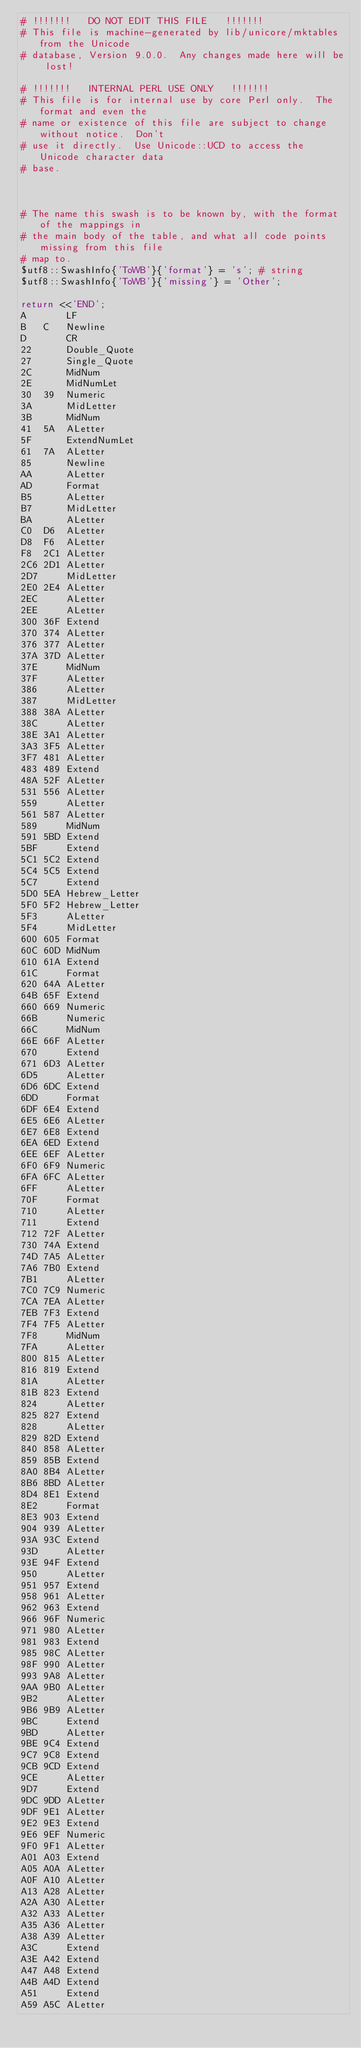<code> <loc_0><loc_0><loc_500><loc_500><_Perl_># !!!!!!!   DO NOT EDIT THIS FILE   !!!!!!!
# This file is machine-generated by lib/unicore/mktables from the Unicode
# database, Version 9.0.0.  Any changes made here will be lost!

# !!!!!!!   INTERNAL PERL USE ONLY   !!!!!!!
# This file is for internal use by core Perl only.  The format and even the
# name or existence of this file are subject to change without notice.  Don't
# use it directly.  Use Unicode::UCD to access the Unicode character data
# base.



# The name this swash is to be known by, with the format of the mappings in
# the main body of the table, and what all code points missing from this file
# map to.
$utf8::SwashInfo{'ToWB'}{'format'} = 's'; # string
$utf8::SwashInfo{'ToWB'}{'missing'} = 'Other';

return <<'END';
A		LF
B	C	Newline
D		CR
22		Double_Quote
27		Single_Quote
2C		MidNum
2E		MidNumLet
30	39	Numeric
3A		MidLetter
3B		MidNum
41	5A	ALetter
5F		ExtendNumLet
61	7A	ALetter
85		Newline
AA		ALetter
AD		Format
B5		ALetter
B7		MidLetter
BA		ALetter
C0	D6	ALetter
D8	F6	ALetter
F8	2C1	ALetter
2C6	2D1	ALetter
2D7		MidLetter
2E0	2E4	ALetter
2EC		ALetter
2EE		ALetter
300	36F	Extend
370	374	ALetter
376	377	ALetter
37A	37D	ALetter
37E		MidNum
37F		ALetter
386		ALetter
387		MidLetter
388	38A	ALetter
38C		ALetter
38E	3A1	ALetter
3A3	3F5	ALetter
3F7	481	ALetter
483	489	Extend
48A	52F	ALetter
531	556	ALetter
559		ALetter
561	587	ALetter
589		MidNum
591	5BD	Extend
5BF		Extend
5C1	5C2	Extend
5C4	5C5	Extend
5C7		Extend
5D0	5EA	Hebrew_Letter
5F0	5F2	Hebrew_Letter
5F3		ALetter
5F4		MidLetter
600	605	Format
60C	60D	MidNum
610	61A	Extend
61C		Format
620	64A	ALetter
64B	65F	Extend
660	669	Numeric
66B		Numeric
66C		MidNum
66E	66F	ALetter
670		Extend
671	6D3	ALetter
6D5		ALetter
6D6	6DC	Extend
6DD		Format
6DF	6E4	Extend
6E5	6E6	ALetter
6E7	6E8	Extend
6EA	6ED	Extend
6EE	6EF	ALetter
6F0	6F9	Numeric
6FA	6FC	ALetter
6FF		ALetter
70F		Format
710		ALetter
711		Extend
712	72F	ALetter
730	74A	Extend
74D	7A5	ALetter
7A6	7B0	Extend
7B1		ALetter
7C0	7C9	Numeric
7CA	7EA	ALetter
7EB	7F3	Extend
7F4	7F5	ALetter
7F8		MidNum
7FA		ALetter
800	815	ALetter
816	819	Extend
81A		ALetter
81B	823	Extend
824		ALetter
825	827	Extend
828		ALetter
829	82D	Extend
840	858	ALetter
859	85B	Extend
8A0	8B4	ALetter
8B6	8BD	ALetter
8D4	8E1	Extend
8E2		Format
8E3	903	Extend
904	939	ALetter
93A	93C	Extend
93D		ALetter
93E	94F	Extend
950		ALetter
951	957	Extend
958	961	ALetter
962	963	Extend
966	96F	Numeric
971	980	ALetter
981	983	Extend
985	98C	ALetter
98F	990	ALetter
993	9A8	ALetter
9AA	9B0	ALetter
9B2		ALetter
9B6	9B9	ALetter
9BC		Extend
9BD		ALetter
9BE	9C4	Extend
9C7	9C8	Extend
9CB	9CD	Extend
9CE		ALetter
9D7		Extend
9DC	9DD	ALetter
9DF	9E1	ALetter
9E2	9E3	Extend
9E6	9EF	Numeric
9F0	9F1	ALetter
A01	A03	Extend
A05	A0A	ALetter
A0F	A10	ALetter
A13	A28	ALetter
A2A	A30	ALetter
A32	A33	ALetter
A35	A36	ALetter
A38	A39	ALetter
A3C		Extend
A3E	A42	Extend
A47	A48	Extend
A4B	A4D	Extend
A51		Extend
A59	A5C	ALetter</code> 